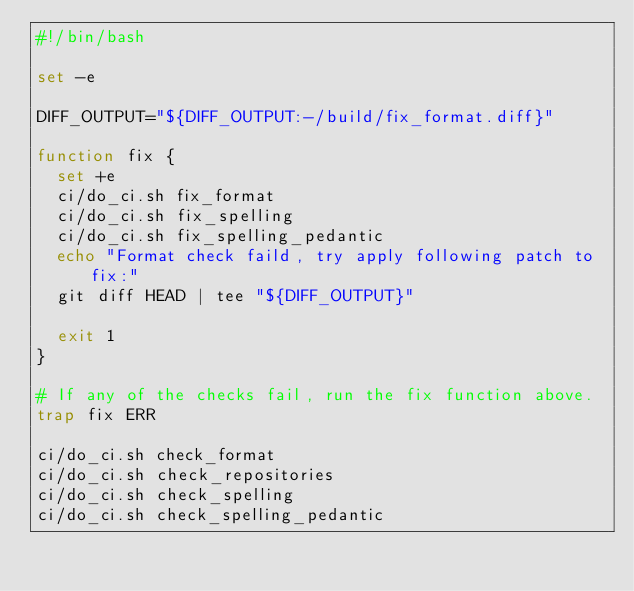<code> <loc_0><loc_0><loc_500><loc_500><_Bash_>#!/bin/bash

set -e

DIFF_OUTPUT="${DIFF_OUTPUT:-/build/fix_format.diff}"

function fix {
  set +e
  ci/do_ci.sh fix_format
  ci/do_ci.sh fix_spelling
  ci/do_ci.sh fix_spelling_pedantic
  echo "Format check faild, try apply following patch to fix:"
  git diff HEAD | tee "${DIFF_OUTPUT}"

  exit 1
}

# If any of the checks fail, run the fix function above.
trap fix ERR

ci/do_ci.sh check_format
ci/do_ci.sh check_repositories
ci/do_ci.sh check_spelling
ci/do_ci.sh check_spelling_pedantic
</code> 